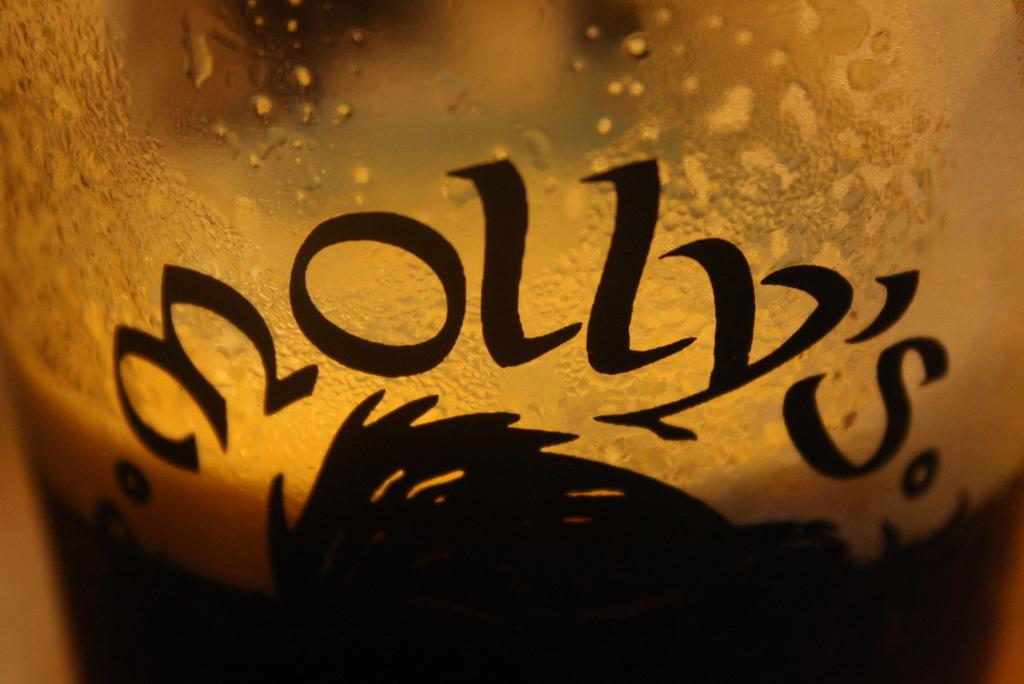<image>
Relay a brief, clear account of the picture shown. A Glass with a drink in it with the word Molly's 